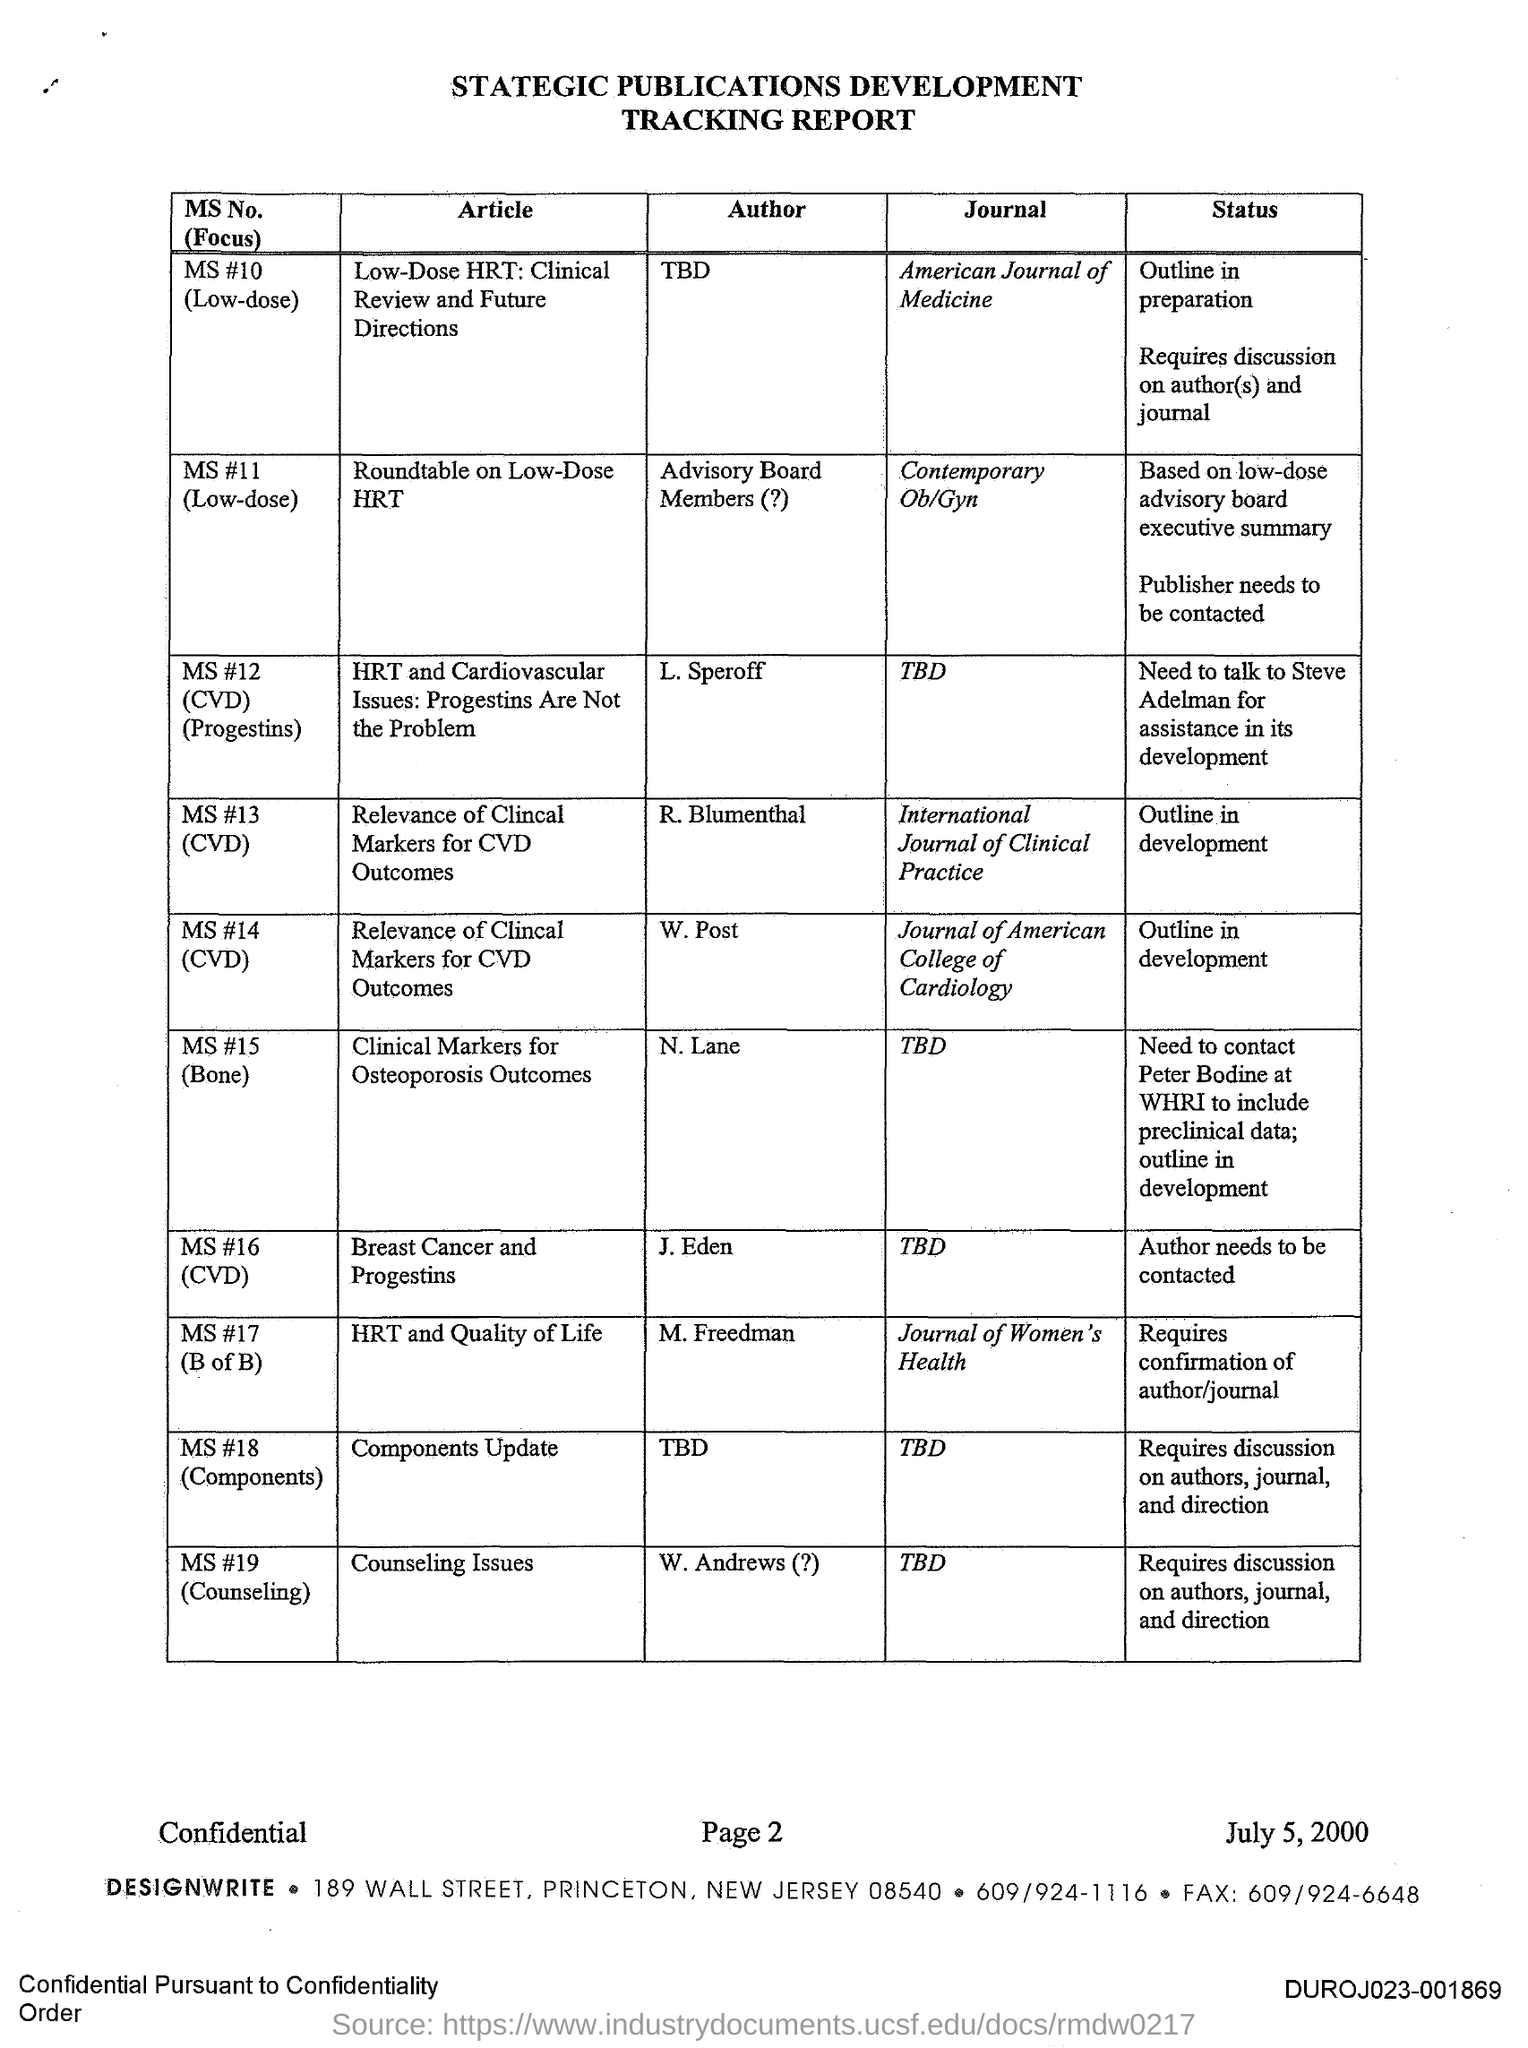List a handful of essential elements in this visual. The article titled "Low-Dose HRT: Clinical Review and Future Directions" was published in the American Journal of Medicine. The article titled "HRT and Quality of Life" was published in the Journal of Women's Health. The author of the article titled "Breast Cancer and Progestins" is J. Eden. 